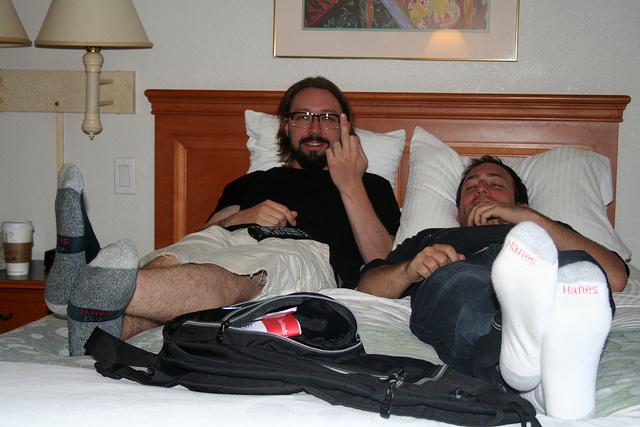Are they laying down?
Short answer required. Yes. What color are the socks?
Concise answer only. White. What kind of socks is the man on the right wearing?
Answer briefly. Hanes. Is there a suitcase on the bed?
Concise answer only. Yes. Which person has longer hair?
Quick response, please. Left. 